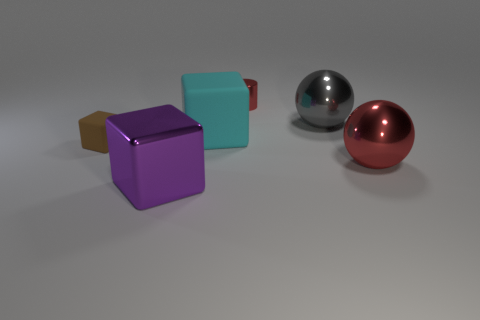What is the material of the big cyan object that is the same shape as the brown rubber object? The big cyan object, sharing the same cubic shape as the brown object, appears to be made of a similar rubber material given its matte surface and light-diffusing properties, which are consistent with rubber characteristics. 